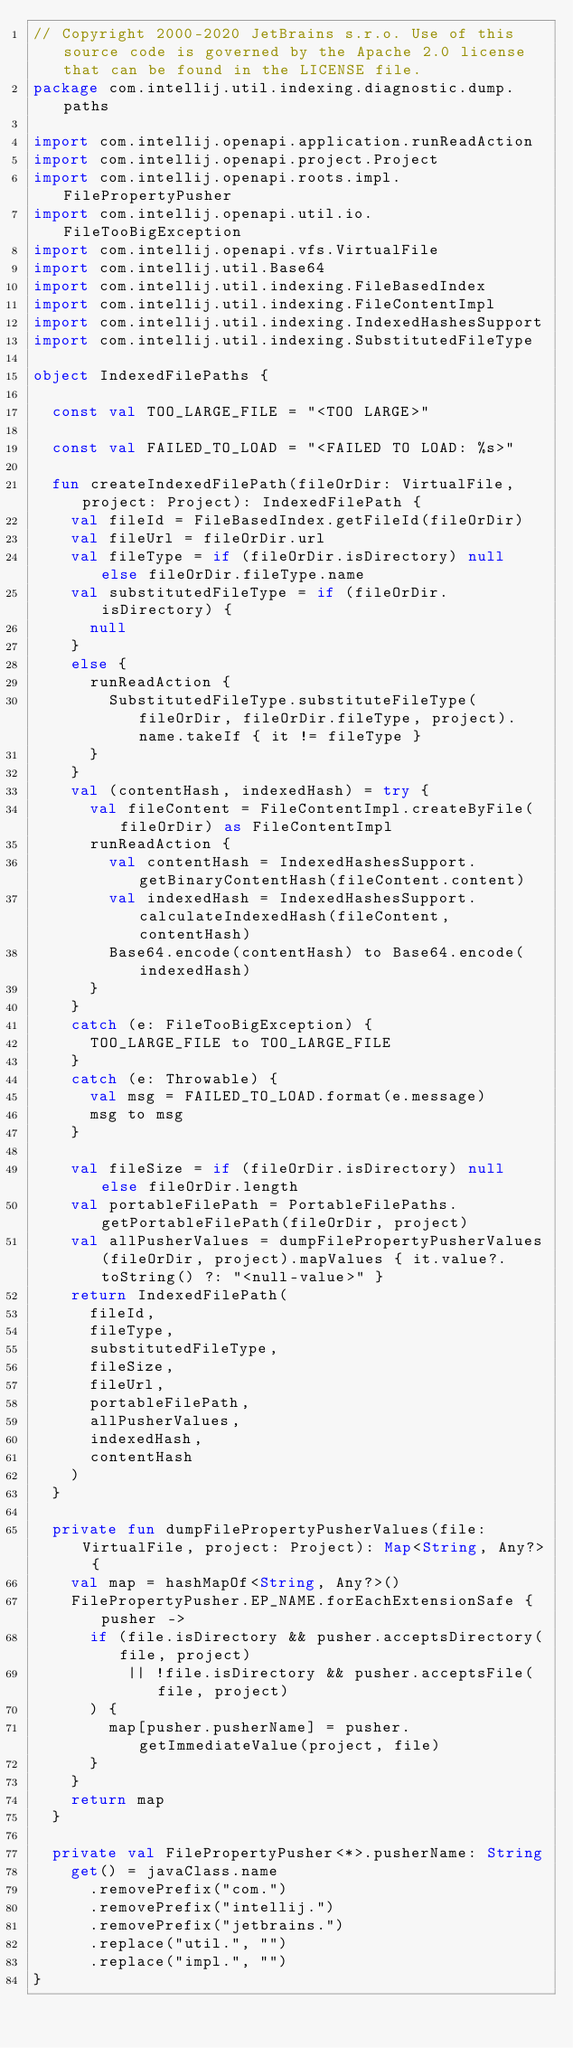Convert code to text. <code><loc_0><loc_0><loc_500><loc_500><_Kotlin_>// Copyright 2000-2020 JetBrains s.r.o. Use of this source code is governed by the Apache 2.0 license that can be found in the LICENSE file.
package com.intellij.util.indexing.diagnostic.dump.paths

import com.intellij.openapi.application.runReadAction
import com.intellij.openapi.project.Project
import com.intellij.openapi.roots.impl.FilePropertyPusher
import com.intellij.openapi.util.io.FileTooBigException
import com.intellij.openapi.vfs.VirtualFile
import com.intellij.util.Base64
import com.intellij.util.indexing.FileBasedIndex
import com.intellij.util.indexing.FileContentImpl
import com.intellij.util.indexing.IndexedHashesSupport
import com.intellij.util.indexing.SubstitutedFileType

object IndexedFilePaths {

  const val TOO_LARGE_FILE = "<TOO LARGE>"

  const val FAILED_TO_LOAD = "<FAILED TO LOAD: %s>"

  fun createIndexedFilePath(fileOrDir: VirtualFile, project: Project): IndexedFilePath {
    val fileId = FileBasedIndex.getFileId(fileOrDir)
    val fileUrl = fileOrDir.url
    val fileType = if (fileOrDir.isDirectory) null else fileOrDir.fileType.name
    val substitutedFileType = if (fileOrDir.isDirectory) {
      null
    }
    else {
      runReadAction {
        SubstitutedFileType.substituteFileType(fileOrDir, fileOrDir.fileType, project).name.takeIf { it != fileType }
      }
    }
    val (contentHash, indexedHash) = try {
      val fileContent = FileContentImpl.createByFile(fileOrDir) as FileContentImpl
      runReadAction {
        val contentHash = IndexedHashesSupport.getBinaryContentHash(fileContent.content)
        val indexedHash = IndexedHashesSupport.calculateIndexedHash(fileContent, contentHash)
        Base64.encode(contentHash) to Base64.encode(indexedHash)
      }
    }
    catch (e: FileTooBigException) {
      TOO_LARGE_FILE to TOO_LARGE_FILE
    }
    catch (e: Throwable) {
      val msg = FAILED_TO_LOAD.format(e.message)
      msg to msg
    }

    val fileSize = if (fileOrDir.isDirectory) null else fileOrDir.length
    val portableFilePath = PortableFilePaths.getPortableFilePath(fileOrDir, project)
    val allPusherValues = dumpFilePropertyPusherValues(fileOrDir, project).mapValues { it.value?.toString() ?: "<null-value>" }
    return IndexedFilePath(
      fileId,
      fileType,
      substitutedFileType,
      fileSize,
      fileUrl,
      portableFilePath,
      allPusherValues,
      indexedHash,
      contentHash
    )
  }

  private fun dumpFilePropertyPusherValues(file: VirtualFile, project: Project): Map<String, Any?> {
    val map = hashMapOf<String, Any?>()
    FilePropertyPusher.EP_NAME.forEachExtensionSafe { pusher ->
      if (file.isDirectory && pusher.acceptsDirectory(file, project)
          || !file.isDirectory && pusher.acceptsFile(file, project)
      ) {
        map[pusher.pusherName] = pusher.getImmediateValue(project, file)
      }
    }
    return map
  }

  private val FilePropertyPusher<*>.pusherName: String
    get() = javaClass.name
      .removePrefix("com.")
      .removePrefix("intellij.")
      .removePrefix("jetbrains.")
      .replace("util.", "")
      .replace("impl.", "")
}</code> 